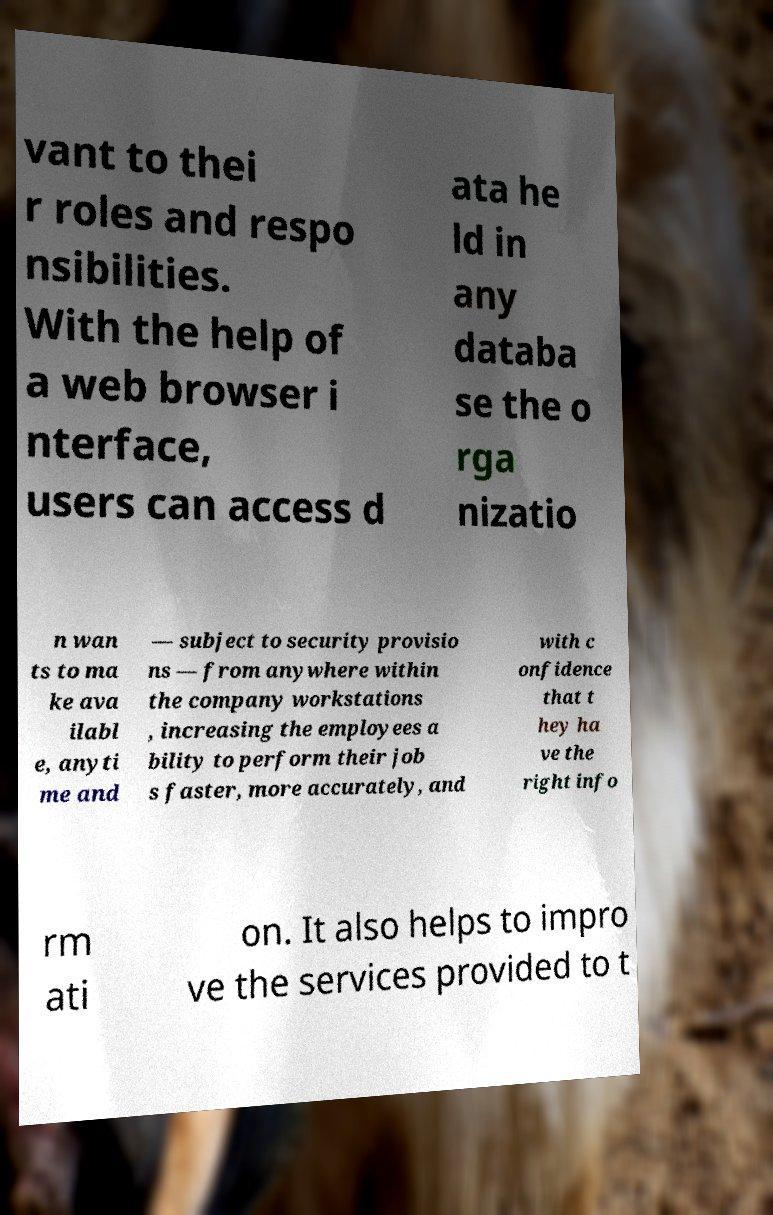I need the written content from this picture converted into text. Can you do that? vant to thei r roles and respo nsibilities. With the help of a web browser i nterface, users can access d ata he ld in any databa se the o rga nizatio n wan ts to ma ke ava ilabl e, anyti me and — subject to security provisio ns — from anywhere within the company workstations , increasing the employees a bility to perform their job s faster, more accurately, and with c onfidence that t hey ha ve the right info rm ati on. It also helps to impro ve the services provided to t 